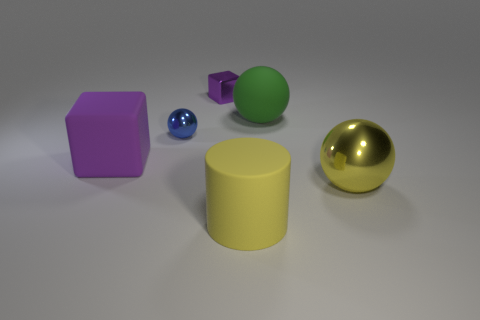Subtract all yellow balls. How many balls are left? 2 Add 3 metallic objects. How many objects exist? 9 Subtract 1 spheres. How many spheres are left? 2 Subtract all blocks. How many objects are left? 4 Add 1 rubber things. How many rubber things exist? 4 Subtract 0 blue blocks. How many objects are left? 6 Subtract all purple spheres. Subtract all purple cylinders. How many spheres are left? 3 Subtract all yellow matte objects. Subtract all tiny things. How many objects are left? 3 Add 5 big yellow shiny balls. How many big yellow shiny balls are left? 6 